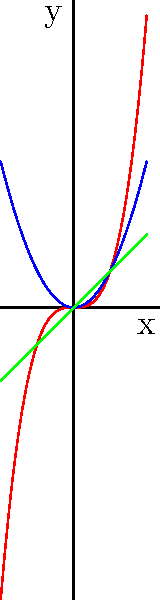比較圖中三條曲線的行為。哪一條曲線在 $x$ 軸正方向增長最快？請用英文回答。

(Translation: Compare the behavior of the three curves in the graph. Which curve grows the fastest in the positive direction of the $x$-axis? Please answer in English.) To answer this question, we need to analyze the behavior of each curve:

1. Green line (Linear): This is a straight line with equation $y = x$. It grows at a constant rate.

2. Blue curve (Quadratic): This is a parabola with equation $y = x^2$. It grows faster than the linear function for $x > 1$.

3. Red curve (Cubic): This has the equation $y = x^3$. For large positive $x$ values, this function grows much faster than both the linear and quadratic functions.

To compare their growth rates:

- For $0 < x < 1$, the order from fastest to slowest is: Linear > Quadratic > Cubic
- For $x = 1$, all functions equal 1
- For $x > 1$, the order from fastest to slowest is: Cubic > Quadratic > Linear

As we're asked about the positive direction of the $x$-axis (i.e., as $x$ increases), we focus on the behavior for large positive $x$ values.

Therefore, the cubic function (red curve) grows the fastest in the positive direction of the $x$-axis.
Answer: The cubic (red) curve grows the fastest. 